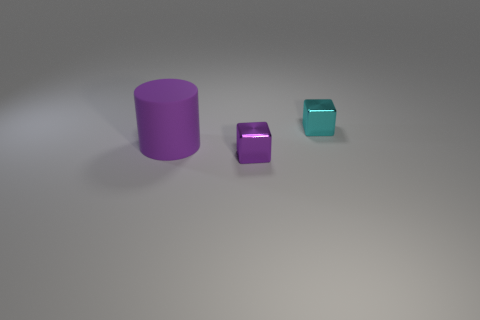Is the shape of the tiny metal object that is in front of the big matte thing the same as the small thing that is behind the cylinder?
Make the answer very short. Yes. There is a metal object that is the same size as the cyan shiny block; what is its shape?
Give a very brief answer. Cube. What number of rubber objects are either large green balls or tiny cyan things?
Offer a terse response. 0. Do the tiny object behind the large cylinder and the purple object behind the tiny purple thing have the same material?
Give a very brief answer. No. The thing that is the same material as the tiny cyan cube is what color?
Provide a succinct answer. Purple. Is the number of purple objects that are behind the cyan metal cube greater than the number of cyan objects that are behind the purple rubber cylinder?
Offer a terse response. No. Are any large shiny cubes visible?
Provide a succinct answer. No. What material is the cube that is the same color as the matte thing?
Provide a succinct answer. Metal. What number of things are big purple objects or tiny purple metal things?
Provide a succinct answer. 2. Is there a large matte cylinder that has the same color as the big object?
Offer a terse response. No. 